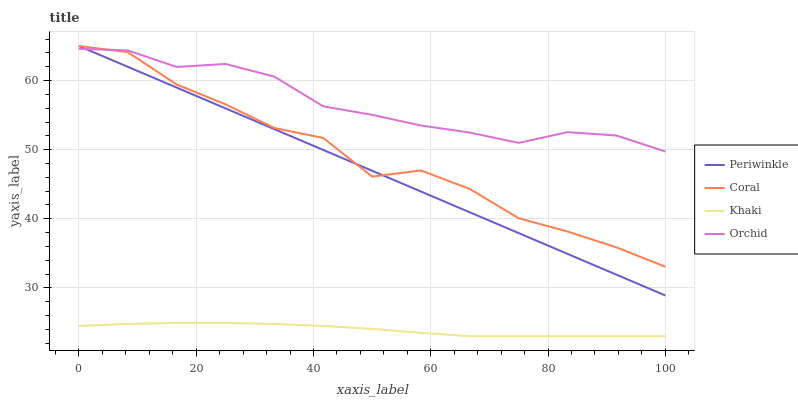Does Khaki have the minimum area under the curve?
Answer yes or no. Yes. Does Periwinkle have the minimum area under the curve?
Answer yes or no. No. Does Periwinkle have the maximum area under the curve?
Answer yes or no. No. Is Periwinkle the smoothest?
Answer yes or no. Yes. Is Coral the roughest?
Answer yes or no. Yes. Is Khaki the smoothest?
Answer yes or no. No. Is Khaki the roughest?
Answer yes or no. No. Does Periwinkle have the lowest value?
Answer yes or no. No. Does Khaki have the highest value?
Answer yes or no. No. Is Khaki less than Orchid?
Answer yes or no. Yes. Is Coral greater than Khaki?
Answer yes or no. Yes. Does Khaki intersect Orchid?
Answer yes or no. No. 